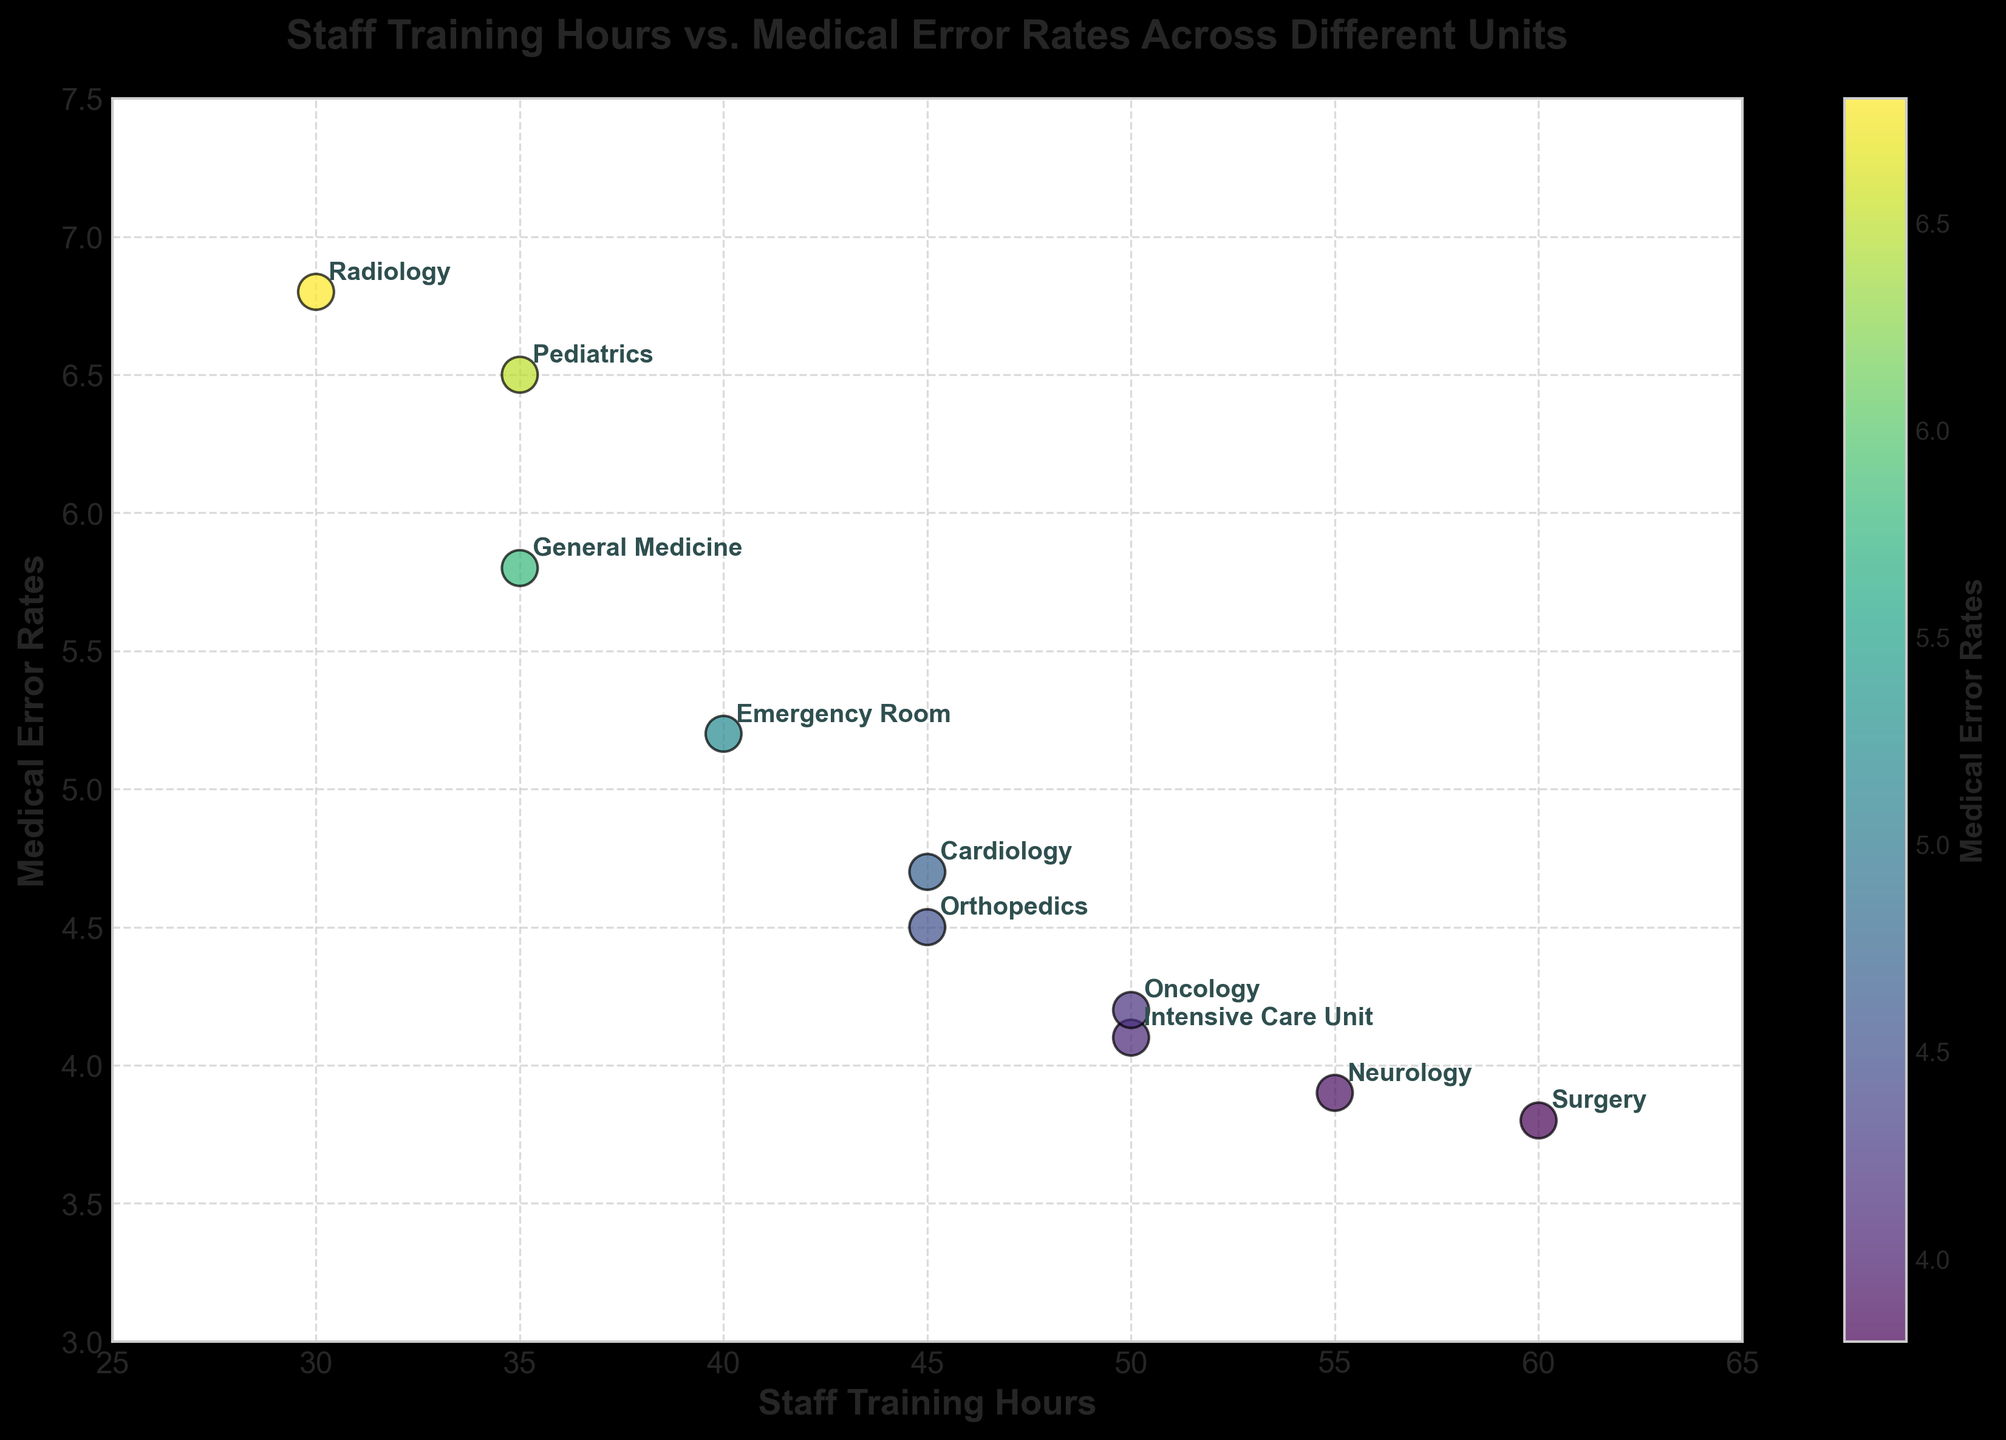What is the title of the plot? The title of the plot is located at the top of the figure, which reads "Staff Training Hours vs. Medical Error Rates Across Different Units."
Answer: Staff Training Hours vs. Medical Error Rates Across Different Units How many units are represented in the plot? By counting the number of labeled data points in the plot, we can see there are 10 units represented in the scatter plot.
Answer: 10 Which unit has the highest medical error rate? By looking at the y-axis, which represents medical error rates, we find the unit with the highest y-value, which is labeled "Radiology" with an error rate of 6.8.
Answer: Radiology What is the relationship between staff training hours and medical error rates? Generally, from visualizing the scatter plot, we observe that units with higher staff training hours tend to have lower medical error rates, suggesting an inverse and negative correlation between these two variables.
Answer: Inverse correlation Which unit has the lowest training hours and what is its medical error rate? The x-axis represents staff training hours. By locating the point with the lowest x-value labeled "Radiology," we see it has 30 training hours and the error rate is 6.8.
Answer: Radiology, 6.8 Compare the medical error rates between the Surgery and Pediatrics units. By locating the points labeled "Surgery" and "Pediatrics" on the y-axis, we see Surgery has an error rate of 3.8, while Pediatrics has an error rate of 6.5. Pediatrics has a higher error rate compared to Surgery.
Answer: Pediatrics has a higher error rate What is the average medical error rate across all units? Summing the medical error rates of all units (5.2 + 4.1 + 6.5 + 3.8 + 4.7 + 3.9 + 6.8 + 4.2 + 4.5 + 5.8) gives 49.5. Dividing by the number of units, 10, yields an average error rate of 4.95.
Answer: 4.95 Which units have a medical error rate less than 4? Observing the plot, the units with y-values less than 4 for error rates are "Surgery" and "Neurology."
Answer: Surgery and Neurology What is the range of staff training hours on the x-axis? The x-axis ranges from 25 to 65 staff training hours, as marked on the plot.
Answer: 25 to 65 Do any units have the same staff training hours but different medical error rates? Observing the plot, the "Intensive Care Unit" and "Oncology" both have 50 staff training hours but have different medical error rates of 4.1 and 4.2, respectively.
Answer: Intensive Care Unit and Oncology 